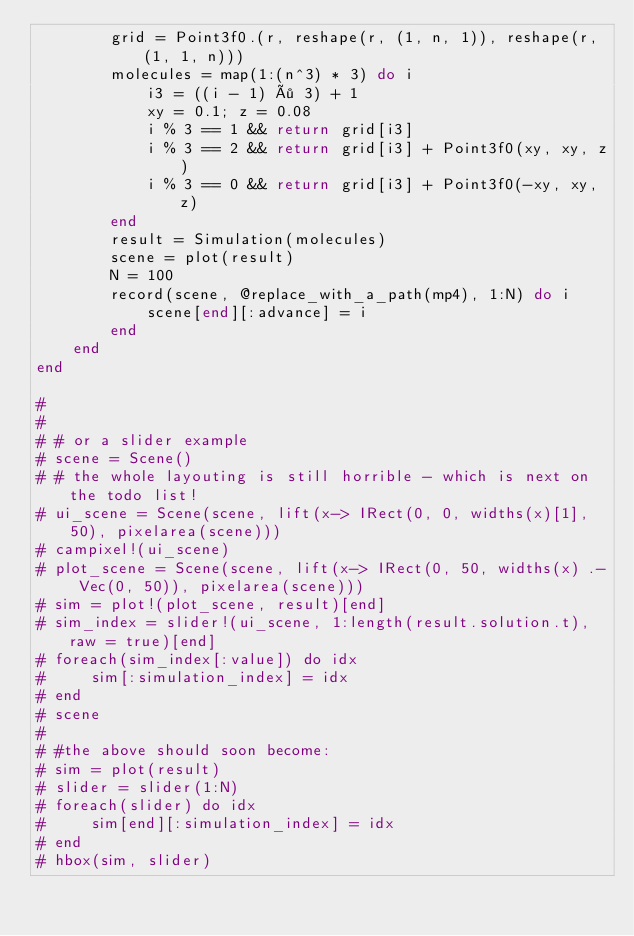<code> <loc_0><loc_0><loc_500><loc_500><_Julia_>        grid = Point3f0.(r, reshape(r, (1, n, 1)), reshape(r, (1, 1, n)))
        molecules = map(1:(n^3) * 3) do i
            i3 = ((i - 1) ÷ 3) + 1
            xy = 0.1; z = 0.08
            i % 3 == 1 && return grid[i3]
            i % 3 == 2 && return grid[i3] + Point3f0(xy, xy, z)
            i % 3 == 0 && return grid[i3] + Point3f0(-xy, xy, z)
        end
        result = Simulation(molecules)
        scene = plot(result)
        N = 100
        record(scene, @replace_with_a_path(mp4), 1:N) do i
            scene[end][:advance] = i
        end
    end
end

#
#
# # or a slider example
# scene = Scene()
# # the whole layouting is still horrible - which is next on the todo list!
# ui_scene = Scene(scene, lift(x-> IRect(0, 0, widths(x)[1], 50), pixelarea(scene)))
# campixel!(ui_scene)
# plot_scene = Scene(scene, lift(x-> IRect(0, 50, widths(x) .- Vec(0, 50)), pixelarea(scene)))
# sim = plot!(plot_scene, result)[end]
# sim_index = slider!(ui_scene, 1:length(result.solution.t), raw = true)[end]
# foreach(sim_index[:value]) do idx
#     sim[:simulation_index] = idx
# end
# scene
#
# #the above should soon become:
# sim = plot(result)
# slider = slider(1:N)
# foreach(slider) do idx
#     sim[end][:simulation_index] = idx
# end
# hbox(sim, slider)
</code> 